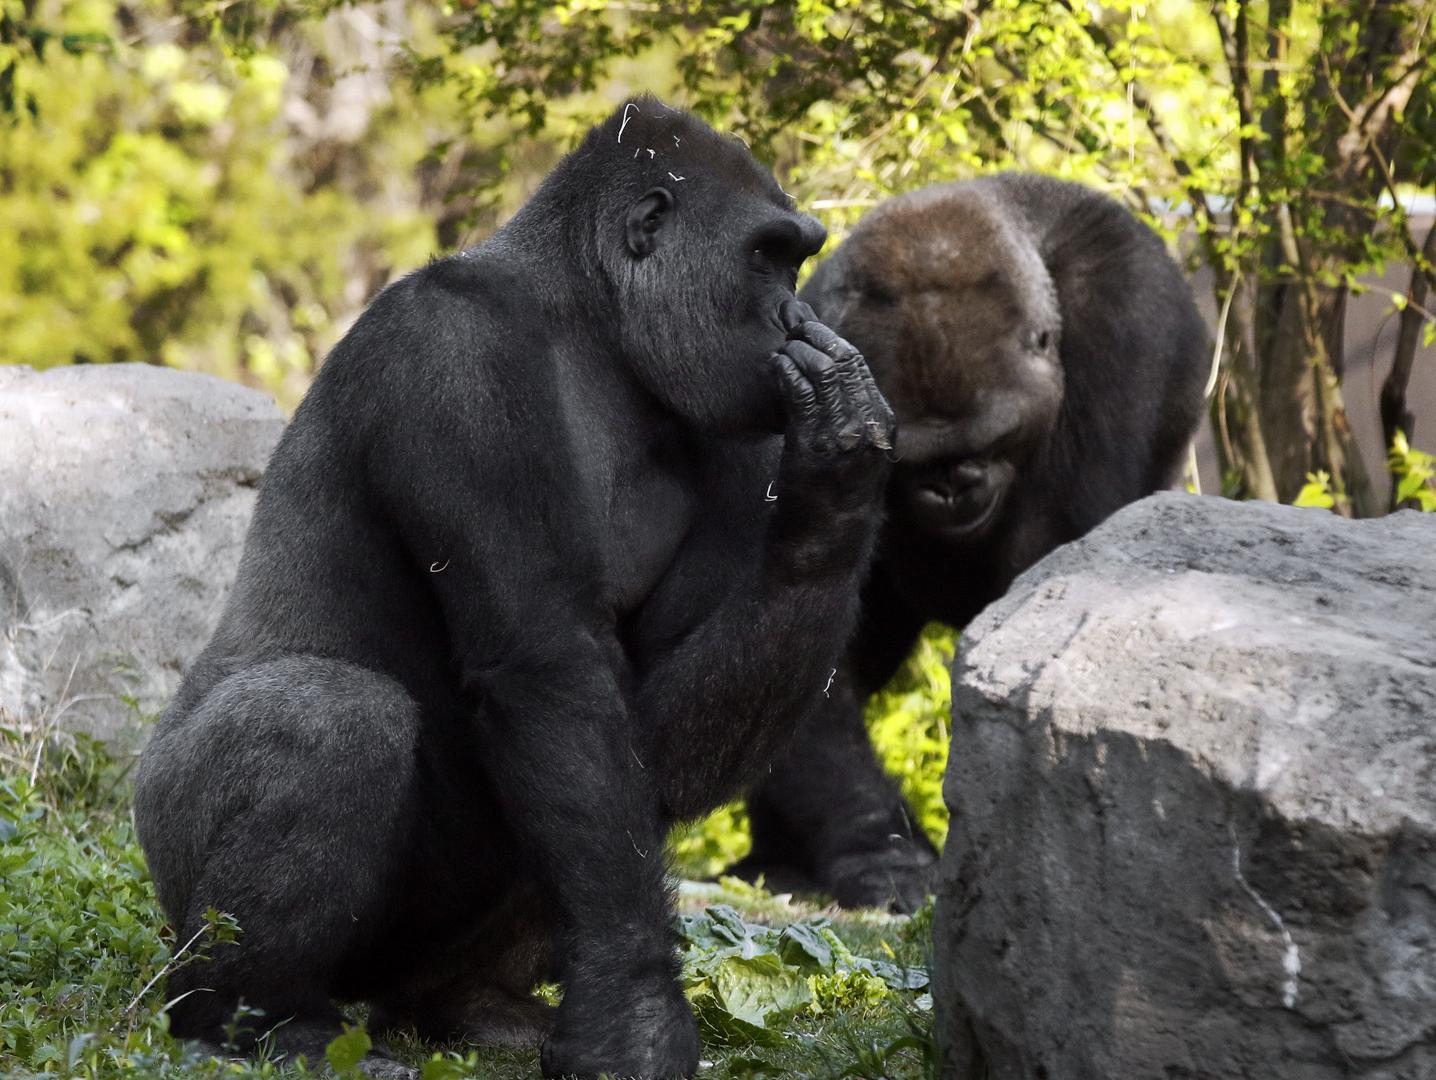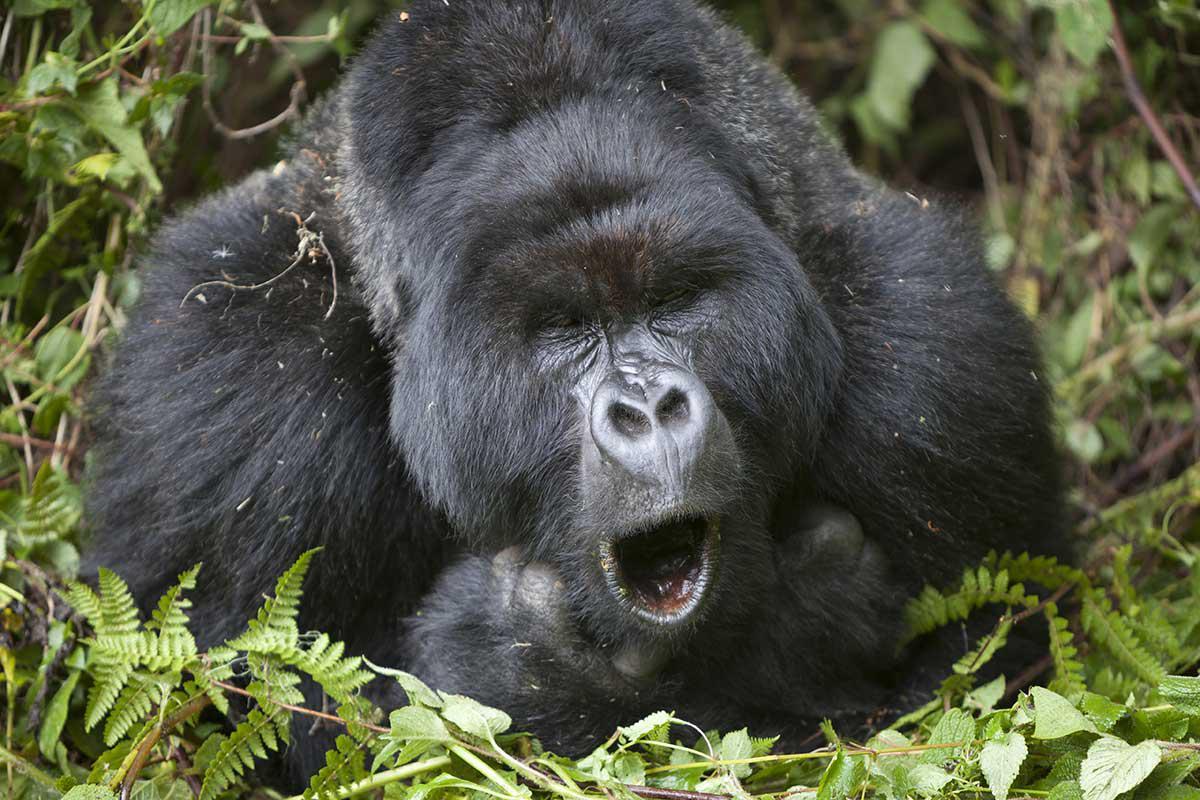The first image is the image on the left, the second image is the image on the right. For the images shown, is this caption "An image shows one forward-turned gorilla standing in a small blue pool splashing water and posed with both arms outstretched horizontally." true? Answer yes or no. No. 